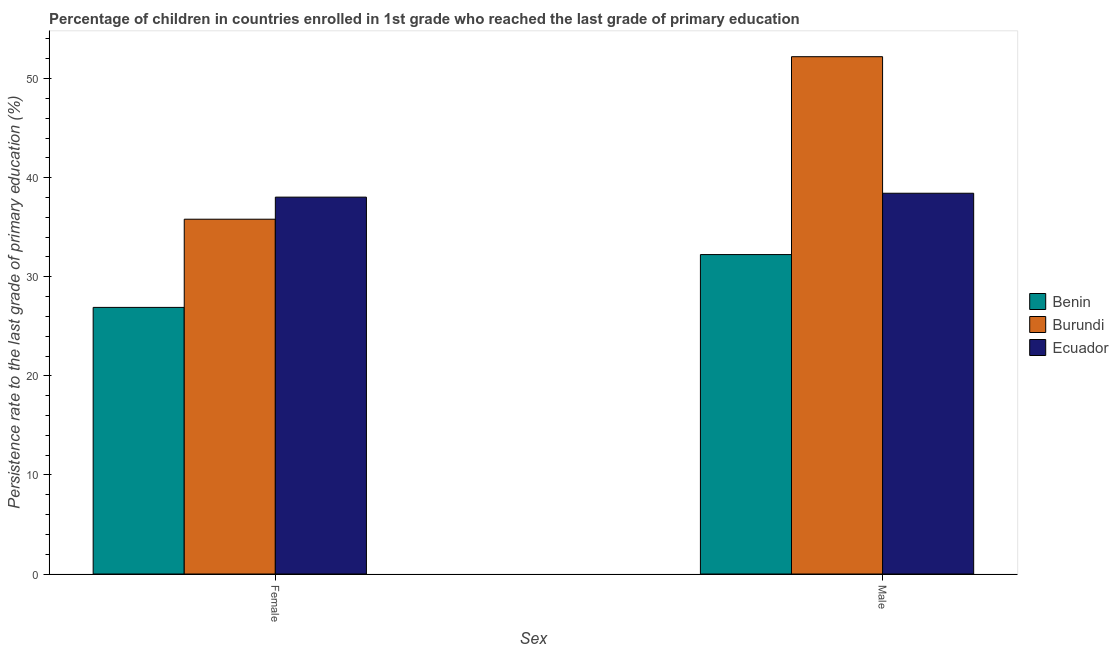How many groups of bars are there?
Offer a very short reply. 2. Are the number of bars per tick equal to the number of legend labels?
Your answer should be very brief. Yes. How many bars are there on the 2nd tick from the right?
Ensure brevity in your answer.  3. What is the persistence rate of female students in Benin?
Make the answer very short. 26.91. Across all countries, what is the maximum persistence rate of male students?
Give a very brief answer. 52.21. Across all countries, what is the minimum persistence rate of female students?
Ensure brevity in your answer.  26.91. In which country was the persistence rate of female students maximum?
Provide a short and direct response. Ecuador. In which country was the persistence rate of male students minimum?
Your answer should be very brief. Benin. What is the total persistence rate of female students in the graph?
Make the answer very short. 100.75. What is the difference between the persistence rate of female students in Burundi and that in Ecuador?
Your response must be concise. -2.23. What is the difference between the persistence rate of male students in Ecuador and the persistence rate of female students in Burundi?
Make the answer very short. 2.62. What is the average persistence rate of female students per country?
Provide a succinct answer. 33.58. What is the difference between the persistence rate of female students and persistence rate of male students in Benin?
Keep it short and to the point. -5.33. What is the ratio of the persistence rate of male students in Burundi to that in Ecuador?
Keep it short and to the point. 1.36. In how many countries, is the persistence rate of female students greater than the average persistence rate of female students taken over all countries?
Your answer should be compact. 2. What does the 1st bar from the left in Female represents?
Give a very brief answer. Benin. What does the 3rd bar from the right in Male represents?
Your answer should be compact. Benin. What is the difference between two consecutive major ticks on the Y-axis?
Give a very brief answer. 10. Are the values on the major ticks of Y-axis written in scientific E-notation?
Give a very brief answer. No. Does the graph contain any zero values?
Offer a very short reply. No. Where does the legend appear in the graph?
Offer a terse response. Center right. How many legend labels are there?
Your answer should be very brief. 3. What is the title of the graph?
Offer a very short reply. Percentage of children in countries enrolled in 1st grade who reached the last grade of primary education. Does "Barbados" appear as one of the legend labels in the graph?
Offer a terse response. No. What is the label or title of the X-axis?
Keep it short and to the point. Sex. What is the label or title of the Y-axis?
Your response must be concise. Persistence rate to the last grade of primary education (%). What is the Persistence rate to the last grade of primary education (%) in Benin in Female?
Your response must be concise. 26.91. What is the Persistence rate to the last grade of primary education (%) of Burundi in Female?
Keep it short and to the point. 35.81. What is the Persistence rate to the last grade of primary education (%) in Ecuador in Female?
Offer a very short reply. 38.04. What is the Persistence rate to the last grade of primary education (%) in Benin in Male?
Give a very brief answer. 32.24. What is the Persistence rate to the last grade of primary education (%) of Burundi in Male?
Ensure brevity in your answer.  52.21. What is the Persistence rate to the last grade of primary education (%) of Ecuador in Male?
Provide a short and direct response. 38.43. Across all Sex, what is the maximum Persistence rate to the last grade of primary education (%) of Benin?
Provide a succinct answer. 32.24. Across all Sex, what is the maximum Persistence rate to the last grade of primary education (%) in Burundi?
Make the answer very short. 52.21. Across all Sex, what is the maximum Persistence rate to the last grade of primary education (%) of Ecuador?
Offer a terse response. 38.43. Across all Sex, what is the minimum Persistence rate to the last grade of primary education (%) in Benin?
Ensure brevity in your answer.  26.91. Across all Sex, what is the minimum Persistence rate to the last grade of primary education (%) of Burundi?
Keep it short and to the point. 35.81. Across all Sex, what is the minimum Persistence rate to the last grade of primary education (%) in Ecuador?
Ensure brevity in your answer.  38.04. What is the total Persistence rate to the last grade of primary education (%) of Benin in the graph?
Offer a very short reply. 59.15. What is the total Persistence rate to the last grade of primary education (%) of Burundi in the graph?
Keep it short and to the point. 88.02. What is the total Persistence rate to the last grade of primary education (%) of Ecuador in the graph?
Provide a succinct answer. 76.47. What is the difference between the Persistence rate to the last grade of primary education (%) of Benin in Female and that in Male?
Keep it short and to the point. -5.33. What is the difference between the Persistence rate to the last grade of primary education (%) in Burundi in Female and that in Male?
Give a very brief answer. -16.4. What is the difference between the Persistence rate to the last grade of primary education (%) in Ecuador in Female and that in Male?
Give a very brief answer. -0.39. What is the difference between the Persistence rate to the last grade of primary education (%) of Benin in Female and the Persistence rate to the last grade of primary education (%) of Burundi in Male?
Your response must be concise. -25.3. What is the difference between the Persistence rate to the last grade of primary education (%) of Benin in Female and the Persistence rate to the last grade of primary education (%) of Ecuador in Male?
Provide a short and direct response. -11.52. What is the difference between the Persistence rate to the last grade of primary education (%) of Burundi in Female and the Persistence rate to the last grade of primary education (%) of Ecuador in Male?
Your answer should be compact. -2.62. What is the average Persistence rate to the last grade of primary education (%) of Benin per Sex?
Your answer should be very brief. 29.57. What is the average Persistence rate to the last grade of primary education (%) of Burundi per Sex?
Offer a terse response. 44.01. What is the average Persistence rate to the last grade of primary education (%) of Ecuador per Sex?
Provide a short and direct response. 38.23. What is the difference between the Persistence rate to the last grade of primary education (%) of Benin and Persistence rate to the last grade of primary education (%) of Burundi in Female?
Your response must be concise. -8.9. What is the difference between the Persistence rate to the last grade of primary education (%) of Benin and Persistence rate to the last grade of primary education (%) of Ecuador in Female?
Keep it short and to the point. -11.13. What is the difference between the Persistence rate to the last grade of primary education (%) of Burundi and Persistence rate to the last grade of primary education (%) of Ecuador in Female?
Your answer should be compact. -2.23. What is the difference between the Persistence rate to the last grade of primary education (%) of Benin and Persistence rate to the last grade of primary education (%) of Burundi in Male?
Your answer should be compact. -19.97. What is the difference between the Persistence rate to the last grade of primary education (%) in Benin and Persistence rate to the last grade of primary education (%) in Ecuador in Male?
Keep it short and to the point. -6.19. What is the difference between the Persistence rate to the last grade of primary education (%) in Burundi and Persistence rate to the last grade of primary education (%) in Ecuador in Male?
Offer a terse response. 13.78. What is the ratio of the Persistence rate to the last grade of primary education (%) of Benin in Female to that in Male?
Offer a very short reply. 0.83. What is the ratio of the Persistence rate to the last grade of primary education (%) of Burundi in Female to that in Male?
Provide a short and direct response. 0.69. What is the difference between the highest and the second highest Persistence rate to the last grade of primary education (%) in Benin?
Make the answer very short. 5.33. What is the difference between the highest and the second highest Persistence rate to the last grade of primary education (%) in Burundi?
Offer a terse response. 16.4. What is the difference between the highest and the second highest Persistence rate to the last grade of primary education (%) in Ecuador?
Your response must be concise. 0.39. What is the difference between the highest and the lowest Persistence rate to the last grade of primary education (%) of Benin?
Your answer should be compact. 5.33. What is the difference between the highest and the lowest Persistence rate to the last grade of primary education (%) in Burundi?
Give a very brief answer. 16.4. What is the difference between the highest and the lowest Persistence rate to the last grade of primary education (%) in Ecuador?
Ensure brevity in your answer.  0.39. 